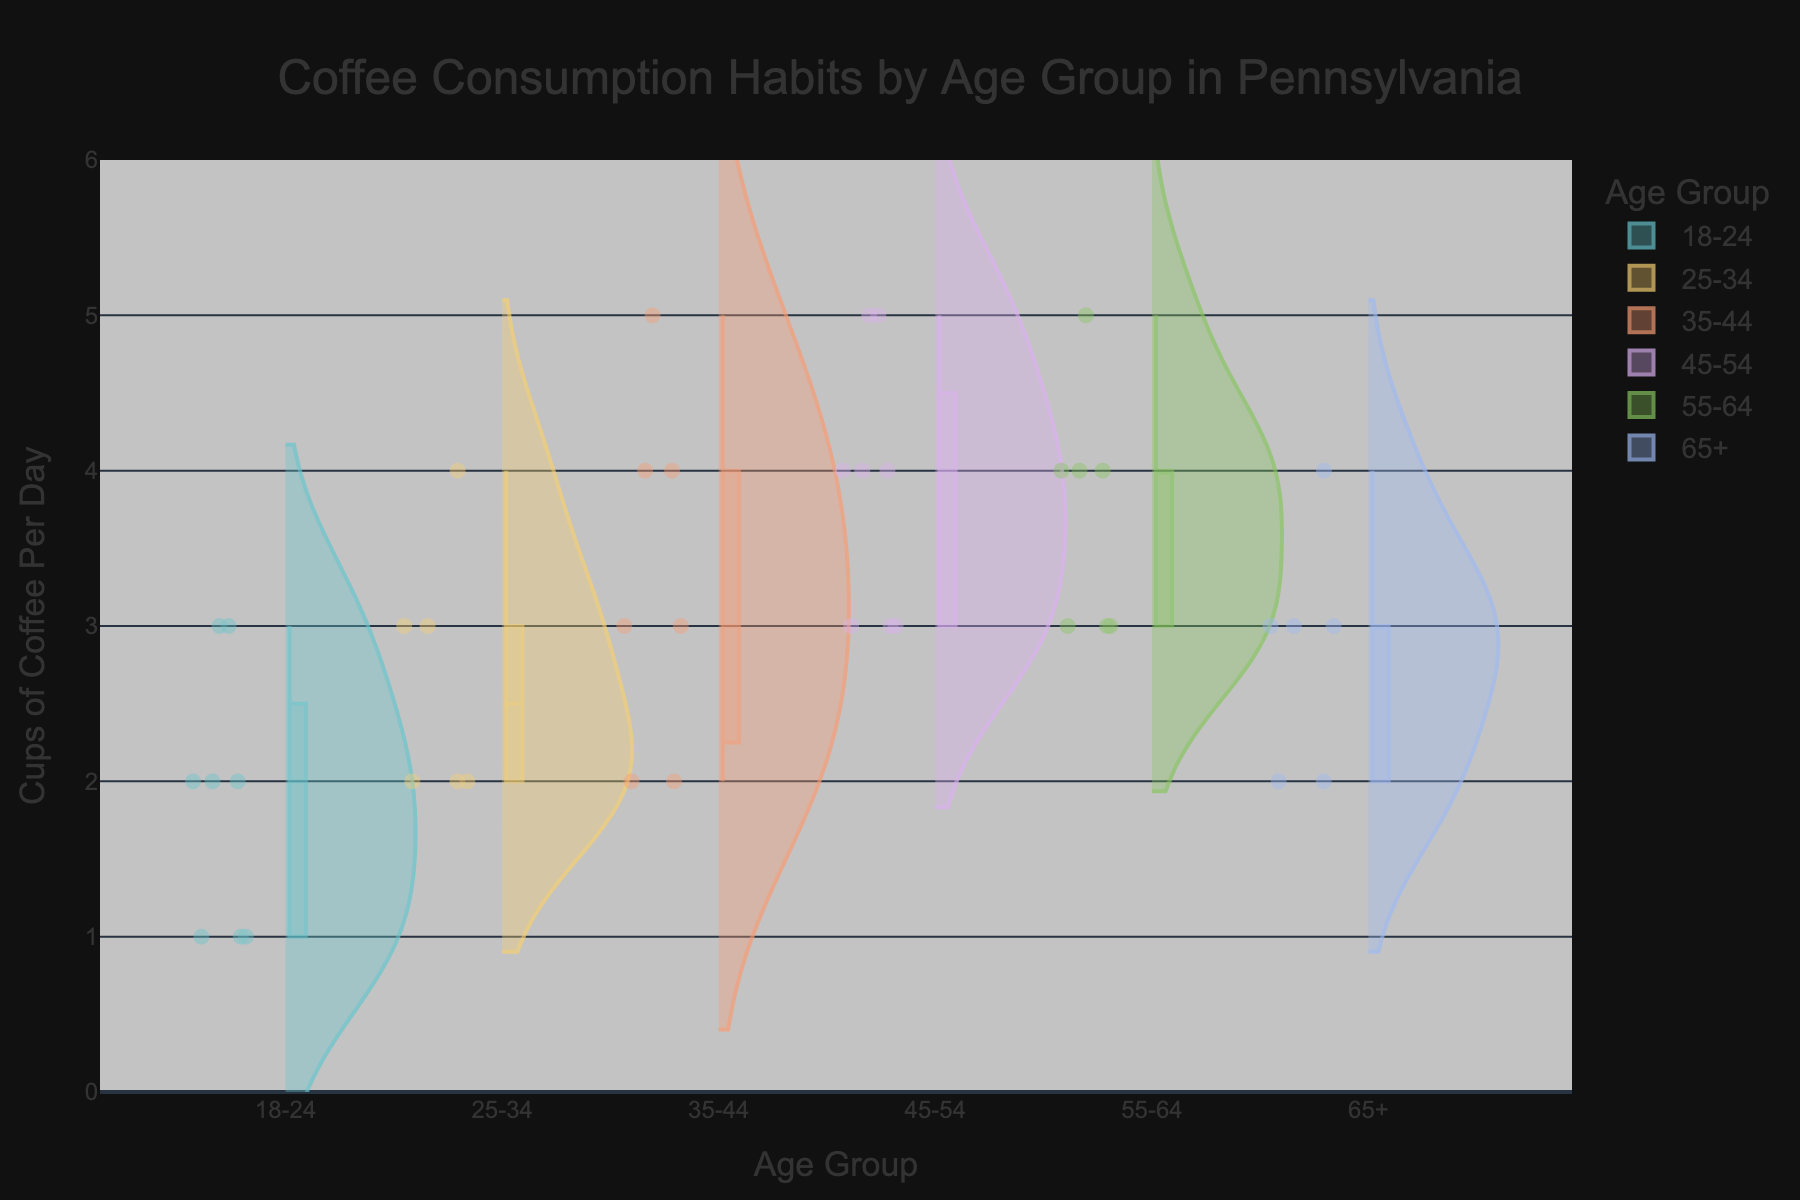What is the title of the figure? The title is typically written at the top center of the figure, and it describes the main topic or data being visualized. Here it reads "Coffee Consumption Habits by Age Group in Pennsylvania".
Answer: Coffee Consumption Habits by Age Group in Pennsylvania What does the y-axis represent? The label on the y-axis indicates what data is being measured. Here, it states "Cups of Coffee Per Day".
Answer: Cups of Coffee Per Day How many age groups are represented in the figure? By counting the distinct categories along the x-axis, we find there are six groups. These are labeled: "18-24", "25-34", "35-44", "45-54", "55-64", and "65+".
Answer: 6 Which age group has the highest median coffee consumption? To find the median, we look at the central line within the box plot of each violin plot. The "45-54" group has the highest median, indicated by the central line at 4 cups.
Answer: 45-54 What is the range of coffee consumption for the 35-44 age group? The range is the difference between the highest and lowest values within the distribution. Observing the violin plot for the "35-44" group, the range is from 2 to 5 cups per day.
Answer: 2 to 5 cups per day Which age group shows the least spread in coffee consumption? The spread of the data is visible in the width of the violin plots. The "18-24" group has the narrowest spread, indicating less variability in consumption.
Answer: 18-24 How many cups of coffee per day does the "65+" age group typically consume? The median value, represented by the line in the middle of the box plot within the violin plot for "65+", indicates typical consumption. It is 3 cups per day.
Answer: 3 cups per day Which age group has individuals consuming up to 5 cups of coffee per day? Observing the upper limit of each violin plot, the age groups "35-44", "45-54", and "55-64" show individuals consuming as many as 5 cups.
Answer: 35-44, 45-54, 55-64 How does the variability of coffee consumption change with age? By comparing the width and spread of the violin plots from left to right (increasing age groups), we notice that the variability tends to increase from "18-24" to "45-54" and is slightly lesser in "55-64" and "65+".
Answer: Increases then slightly decreases 